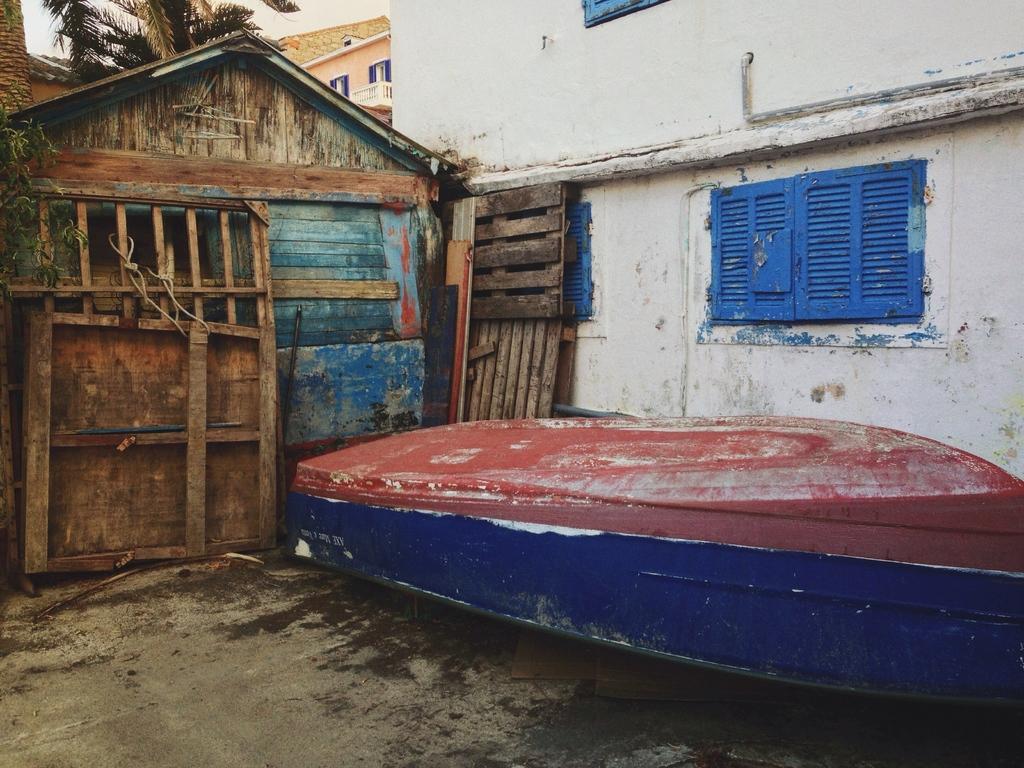Describe this image in one or two sentences. In this image we can see houses. There is a tree. There is a boat. At the bottom of the image there is floor. 